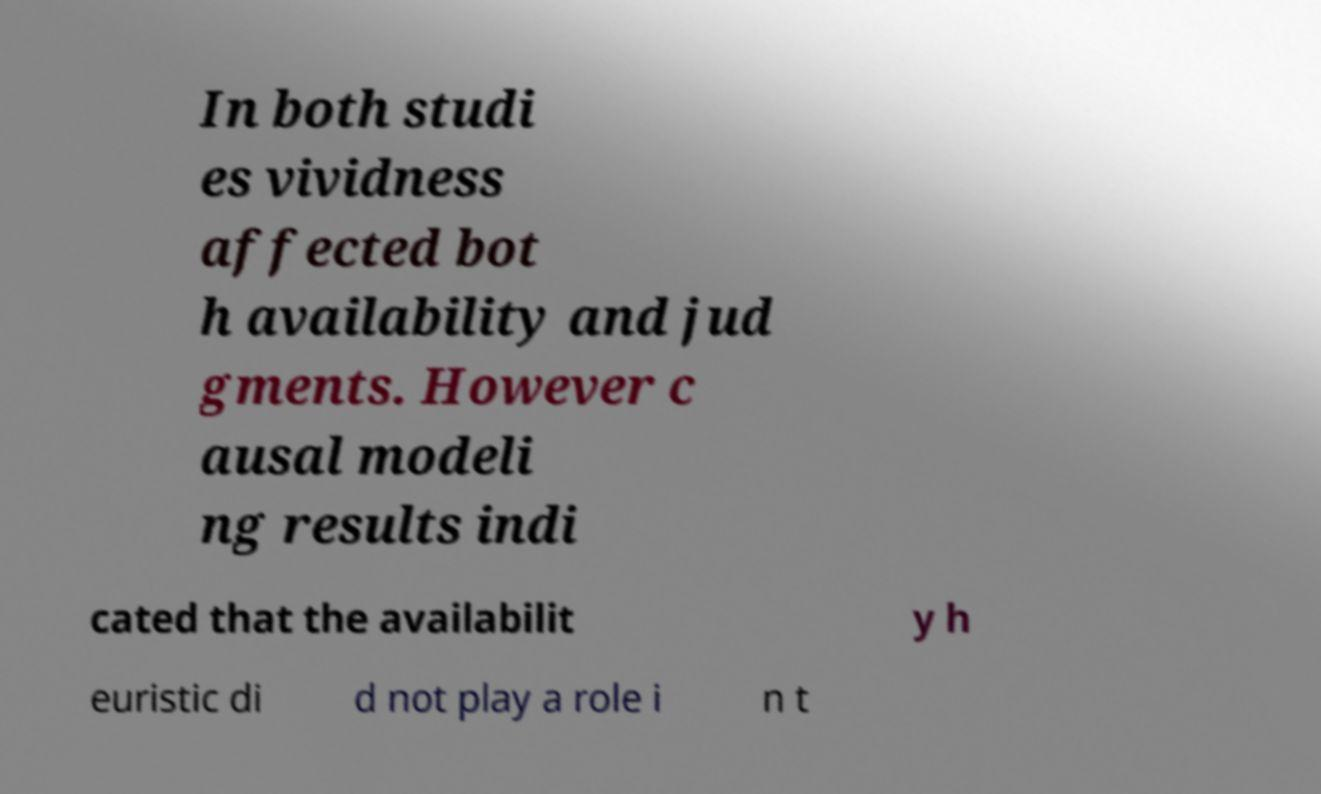Please identify and transcribe the text found in this image. In both studi es vividness affected bot h availability and jud gments. However c ausal modeli ng results indi cated that the availabilit y h euristic di d not play a role i n t 